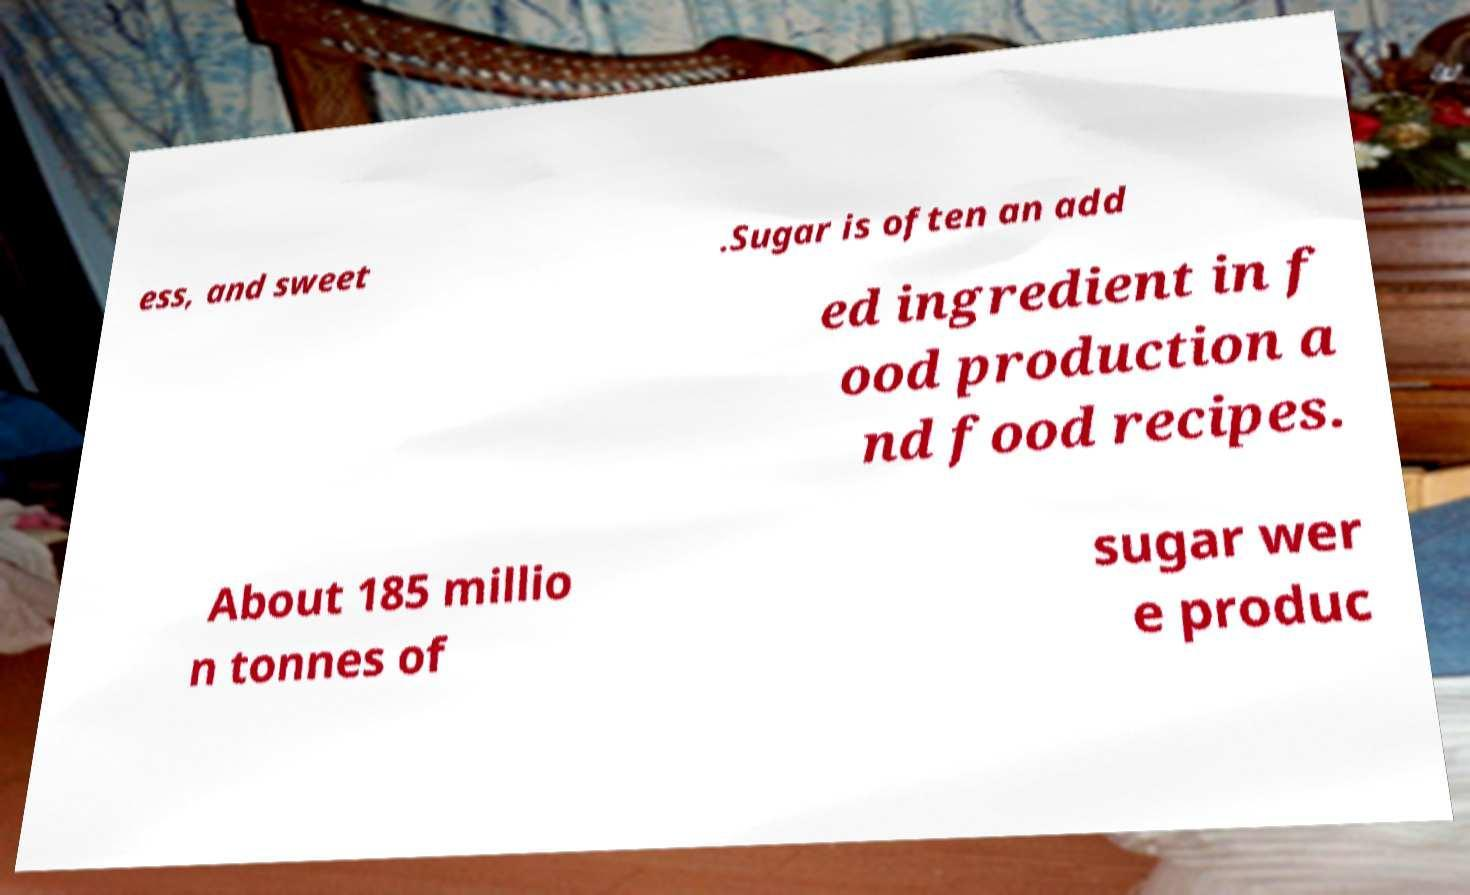Could you extract and type out the text from this image? ess, and sweet .Sugar is often an add ed ingredient in f ood production a nd food recipes. About 185 millio n tonnes of sugar wer e produc 